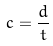<formula> <loc_0><loc_0><loc_500><loc_500>c = \frac { d } { t }</formula> 